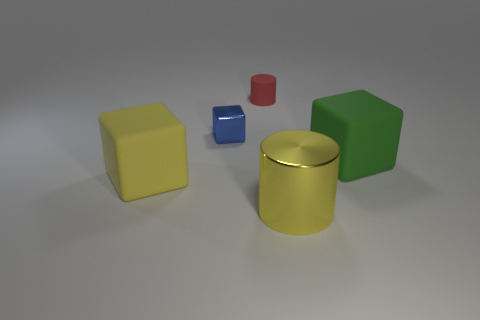Add 2 shiny blocks. How many objects exist? 7 Subtract all cylinders. How many objects are left? 3 Add 3 tiny red cylinders. How many tiny red cylinders exist? 4 Subtract 1 yellow cylinders. How many objects are left? 4 Subtract all large green rubber objects. Subtract all big red shiny spheres. How many objects are left? 4 Add 4 small rubber objects. How many small rubber objects are left? 5 